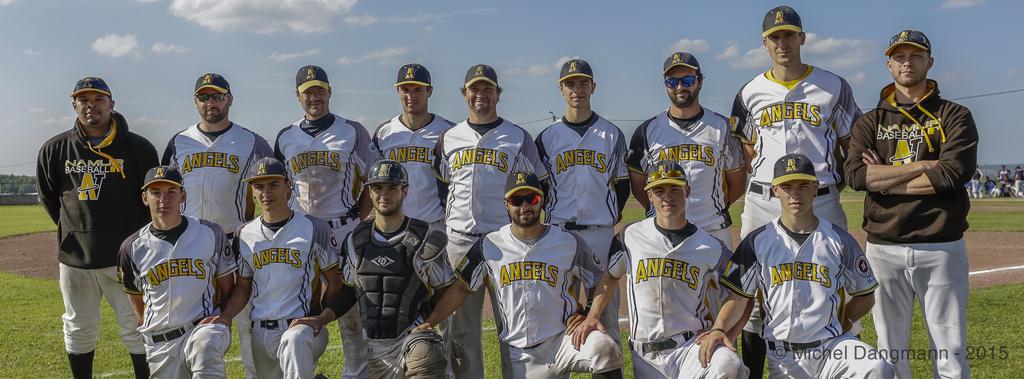Which team do the players play for?
Ensure brevity in your answer.  Angels. What sport is shown on the man's sweatshirt in the back row?
Give a very brief answer. Baseball. 